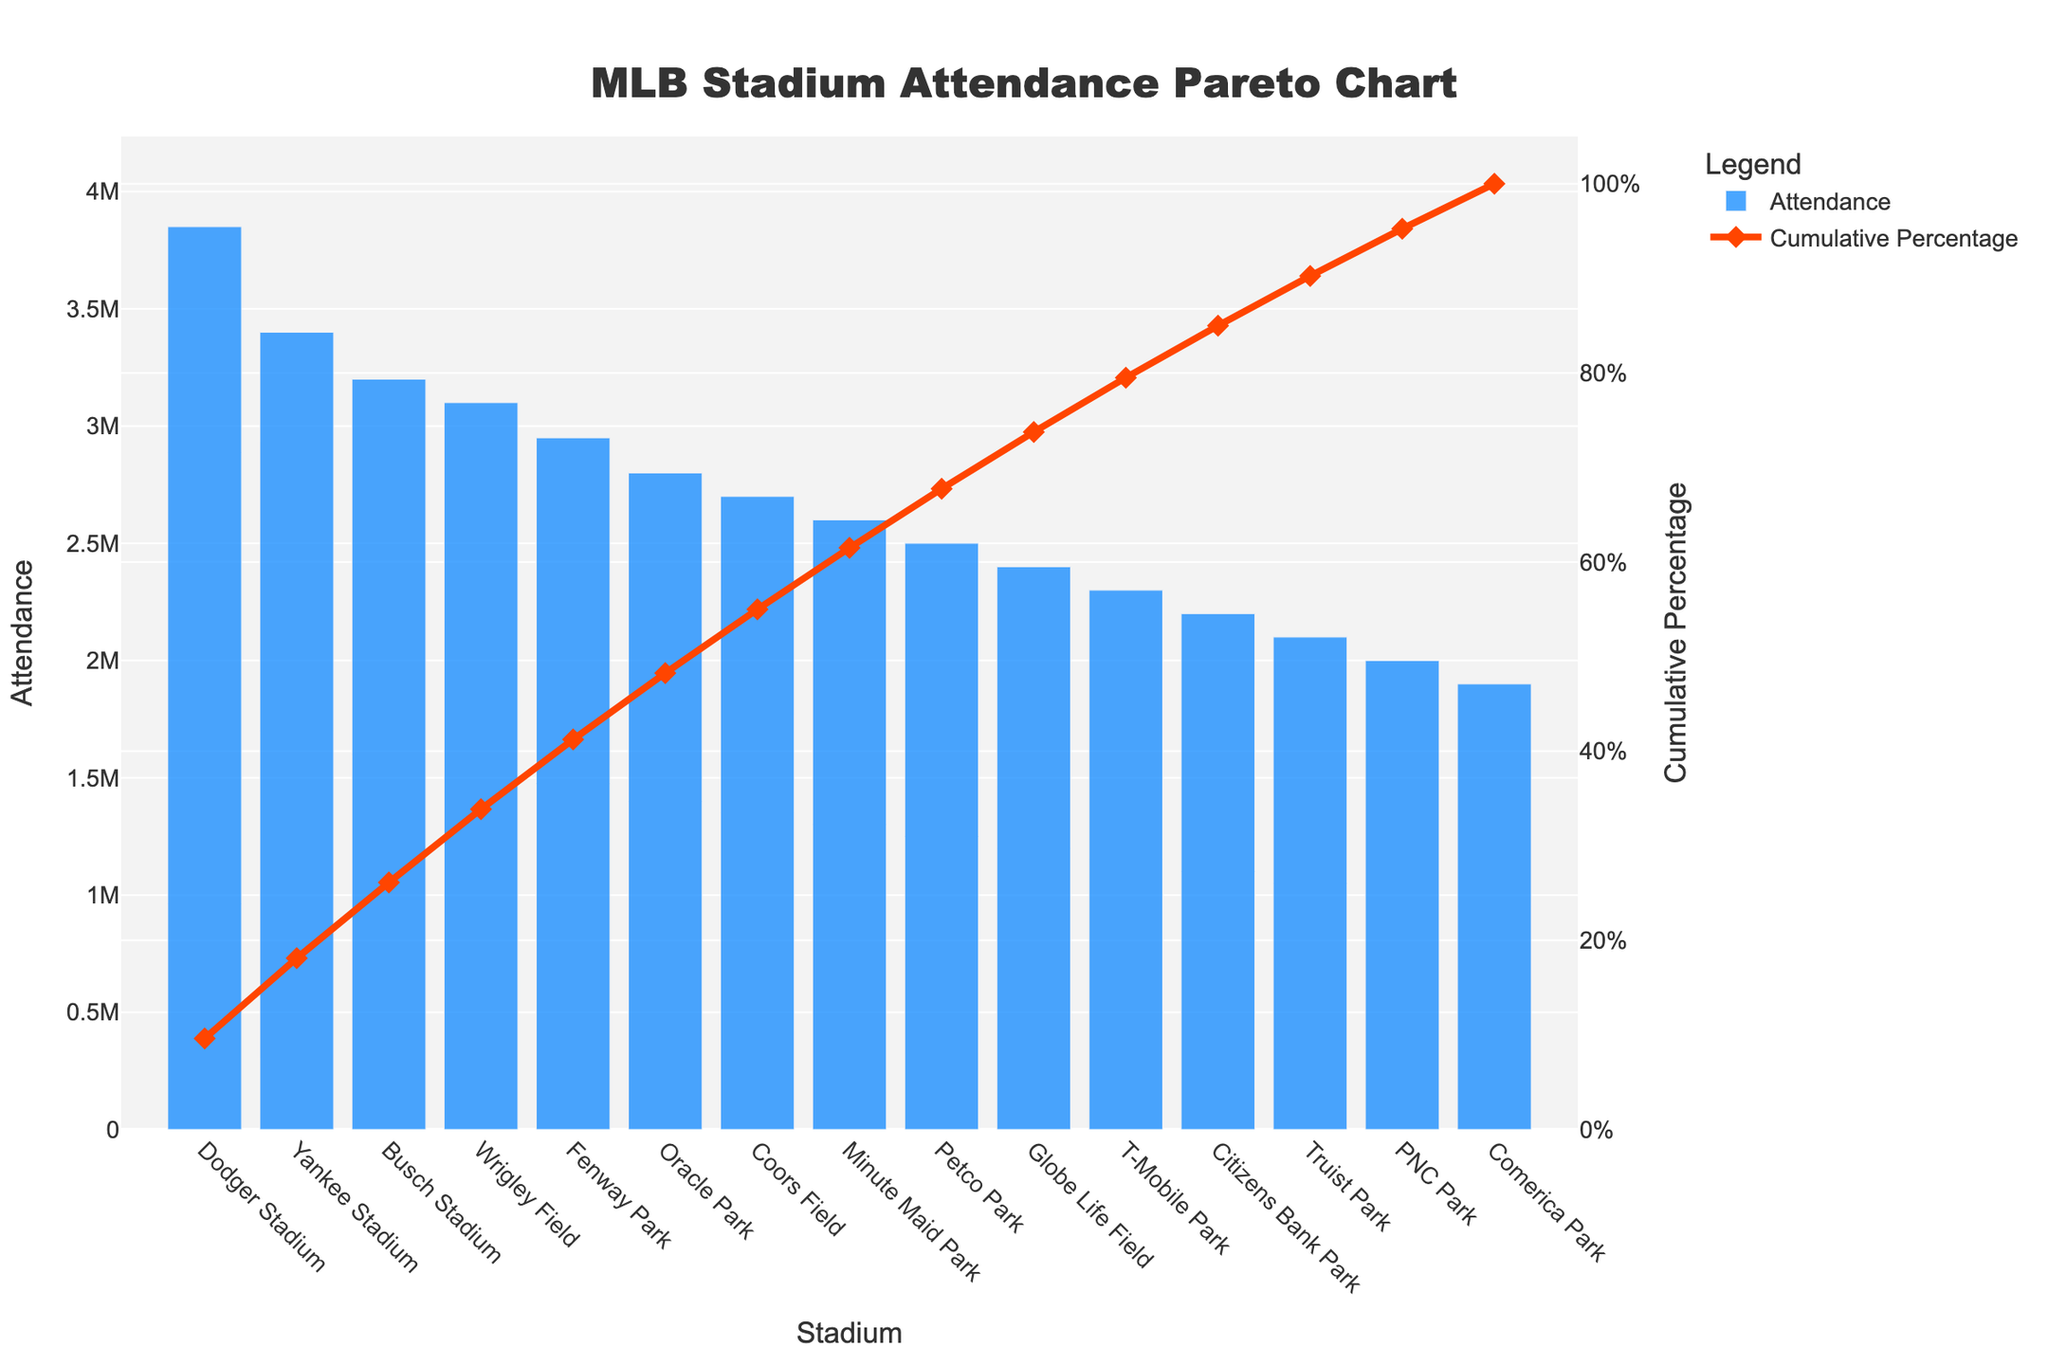Which stadium has the highest attendance? The highest bar in the chart represents the stadium with the highest attendance. The x-axis label corresponding to this bar shows "Dodger Stadium".
Answer: Dodger Stadium What is the cumulative percentage at Fenway Park? Locate the point where the cumulative percentage line intersects the x-axis label "Fenway Park". The corresponding y-axis on the right shows approximately 71%.
Answer: 71% How many stadiums have an attendance greater than or equal to 3,000,000? Count the bars that reach or exceed the 3,000,000 mark on the y-axis. Dodger Stadium, Yankee Stadium, Busch Stadium, and Wrigley Field meet this requirement.
Answer: 4 What's the difference in attendance between Oracle Park and Minute Maid Park? Find the bar heights for Oracle Park and Minute Maid Park on the primary y-axis (attendance). Oracle Park has 2,800,000, and Minute Maid Park has 2,600,000. Subtracting these gives 200,000.
Answer: 200,000 Which stadium is the last one contributing to over 90% cumulative attendance? Trace the cumulative percentage line until it intersects just above the 90% mark on the secondary y-axis, and find the corresponding stadium on the x-axis, which is T-Mobile Park.
Answer: T-Mobile Park What is the attendance at Citizens Bank Park? Identify the height of the bar labeled "Citizens Bank Park" on the x-axis. The corresponding height on the primary y-axis (attendance) is 2,200,000.
Answer: 2,200,000 How many stadiums have a cumulative percentage at or above 70%? Follow the cumulative percentage line until it intersects just above the 70% mark on the secondary y-axis, and count the number of stadiums up to that point. There are five: Dodger Stadium, Yankee Stadium, Busch Stadium, Wrigley Field, and Fenway Park.
Answer: 5 What is the median attendance across all the stadiums? List the attendances in ascending order and find the middle value. The sorted attendances are: 1900000, 2000000, 2100000, 2200000, 2300000, 2400000, 2500000, 2600000, 2700000, 2800000, 2950000, 3100000, 3200000, 3400000, 3850000. The median value (8th in the list) is 2600000 (Minute Maid Park).
Answer: 2,600,000 Which stadium has the lowest attendance? The smallest bar in the chart represents the stadium with the lowest attendance. The x-axis label corresponding to this bar shows "Comerica Park".
Answer: Comerica Park 